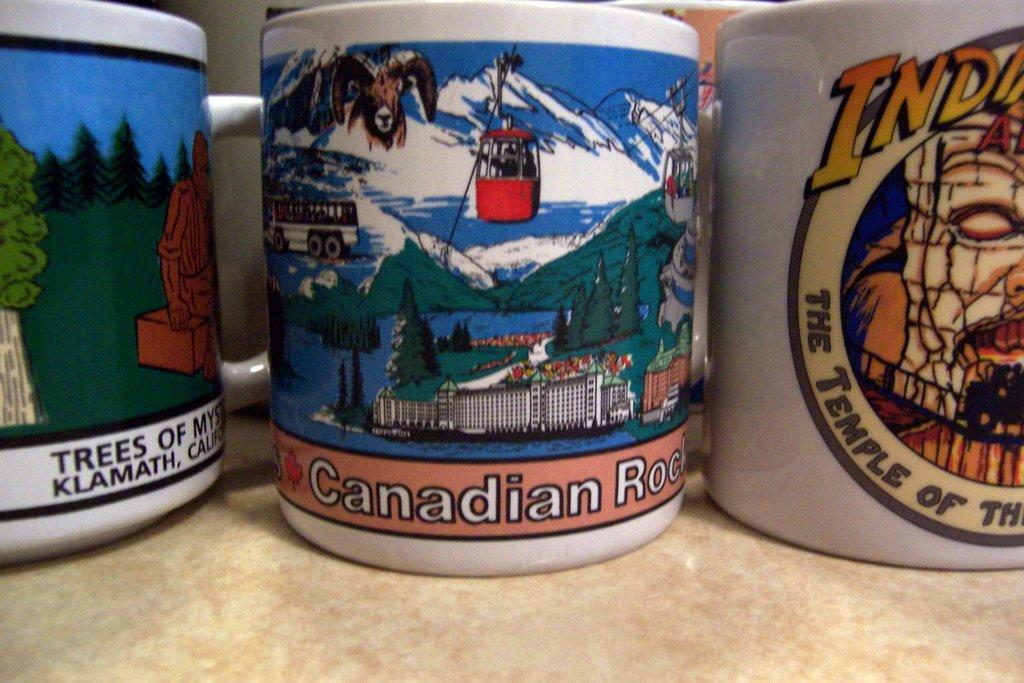Can you describe this image briefly? In this image, we can see three cups which are placed on the table. In the background, we can also see another two cups. 